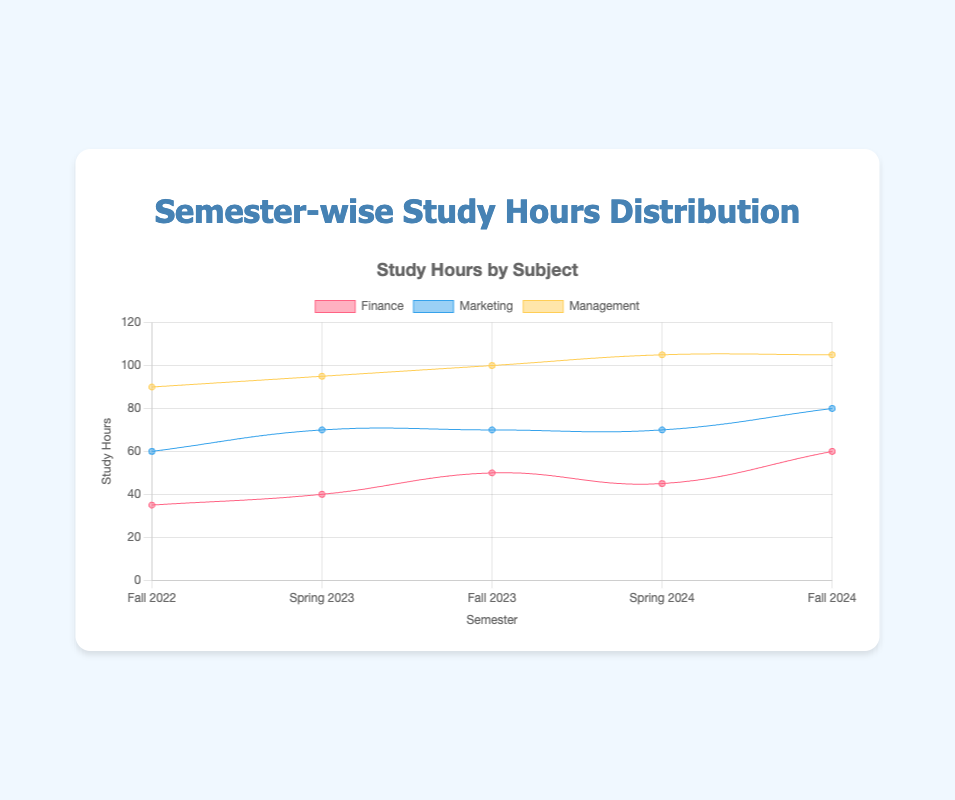What is the title of the chart? The title is typically displayed at the top of the chart. Here, it reads "Semester-wise Study Hours Distribution".
Answer: Semester-wise Study Hours Distribution Which major subject had the highest study hours in Fall 2024? To determine this, we compare the study hours for Finance, Marketing, and Management in Fall 2024 and identify the highest value. Finance had 60 hours compared to Marketing’s 20 and Management’s 25.
Answer: Finance How did the study hours for Marketing change from Spring 2023 to Fall 2023? We look at Marketing's study hours in Spring 2023 (30) and Fall 2023 (20). The difference is 30 - 20 = 10 hours. Thus, the study hours for Marketing decreased by 10 hours.
Answer: Decreased by 10 hours What is the total number of study hours for all subjects in Spring 2024? We sum the study hours for Finance, Marketing, and Management in Spring 2024. Finance: 45, Marketing: 25, Management: 35. Total = 45 + 25 + 35 = 105 hours.
Answer: 105 hours Which semester had the lowest total study hours for Finance? By comparing Finance study hours across all semesters: Fall 2022 (35), Spring 2023 (40), Fall 2023 (50), Spring 2024 (45), and Fall 2024 (60), the lowest total occurs in Fall 2022.
Answer: Fall 2022 Comparing Fall 2023 and Spring 2024, which semester saw a higher combined study hours for Management and Finance? We sum the study hours for Finance and Management for each semester separately: Fall 2023 (Finance: 50, Management: 30) = 80, Spring 2024 (Finance: 45, Management: 35) = 80. Both semesters have the same combined hours for these subjects.
Answer: Both are equal Between Marketing and Management, which subject showed a more consistent pattern in study hours over the semesters? By observing the data: Marketing (25, 30, 20, 25, 20) fluctuates more than Management (30, 25, 30, 35, 25). Management shows less variation in values.
Answer: Management What is the average number of study hours for Marketing for all the semesters combined? Sum the study hours of Marketing for all semesters and divide by the number of semesters: (25 + 30 + 20 + 25 + 20) / 5 = 120 / 5 = 24 hours.
Answer: 24 hours 